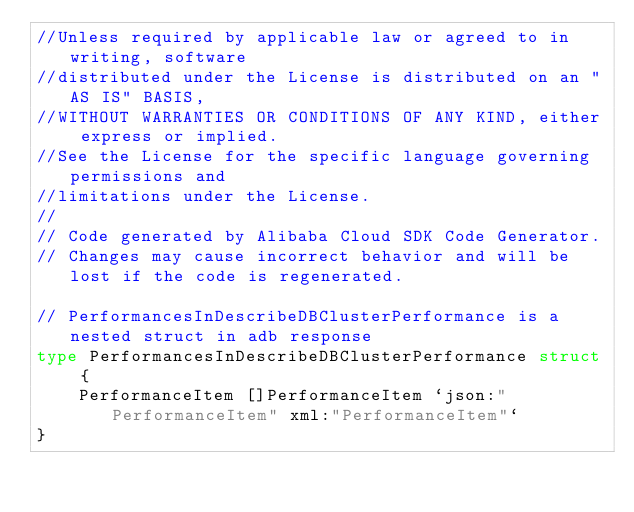<code> <loc_0><loc_0><loc_500><loc_500><_Go_>//Unless required by applicable law or agreed to in writing, software
//distributed under the License is distributed on an "AS IS" BASIS,
//WITHOUT WARRANTIES OR CONDITIONS OF ANY KIND, either express or implied.
//See the License for the specific language governing permissions and
//limitations under the License.
//
// Code generated by Alibaba Cloud SDK Code Generator.
// Changes may cause incorrect behavior and will be lost if the code is regenerated.

// PerformancesInDescribeDBClusterPerformance is a nested struct in adb response
type PerformancesInDescribeDBClusterPerformance struct {
	PerformanceItem []PerformanceItem `json:"PerformanceItem" xml:"PerformanceItem"`
}
</code> 